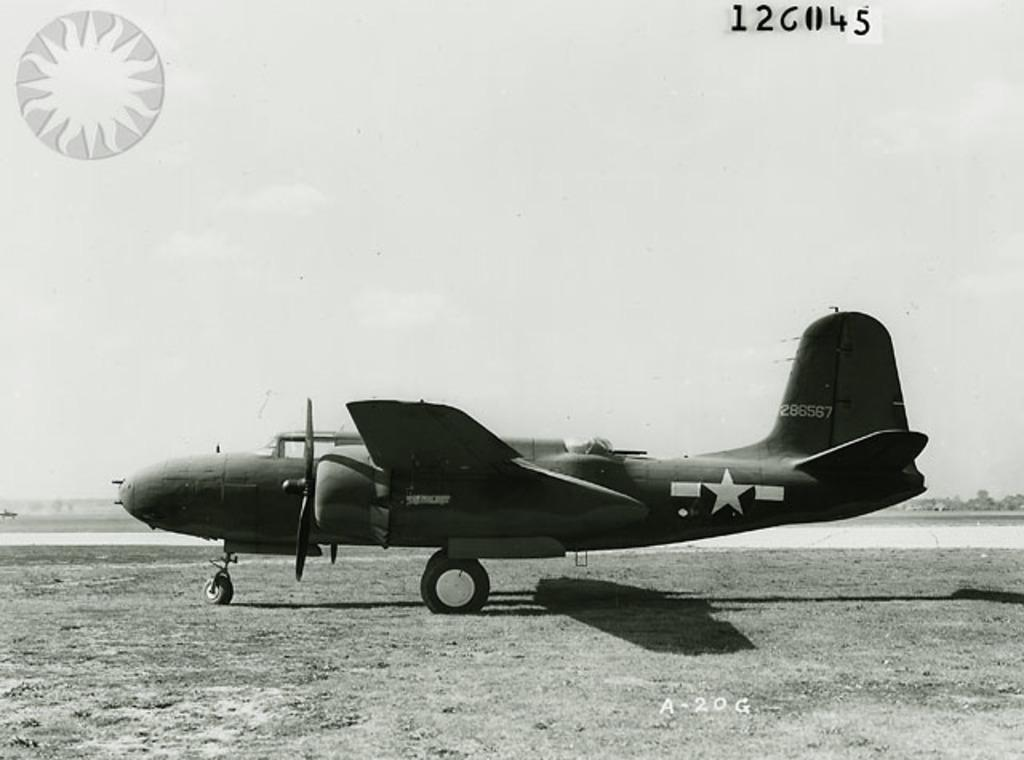<image>
Write a terse but informative summary of the picture. An old photo of a military plane parked on grass with the designation of A-20G on the photo. 